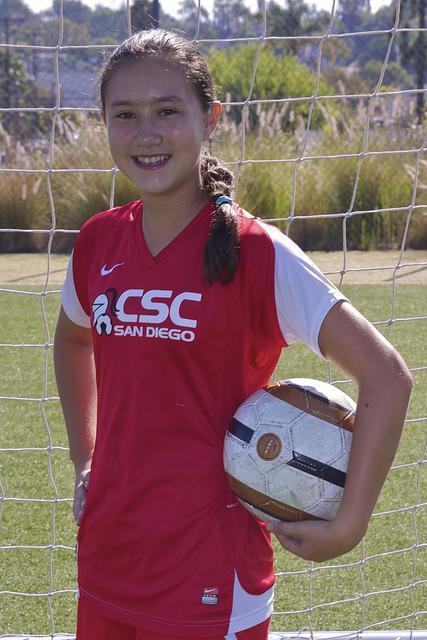How many trains are in the picture?
Give a very brief answer. 0. 